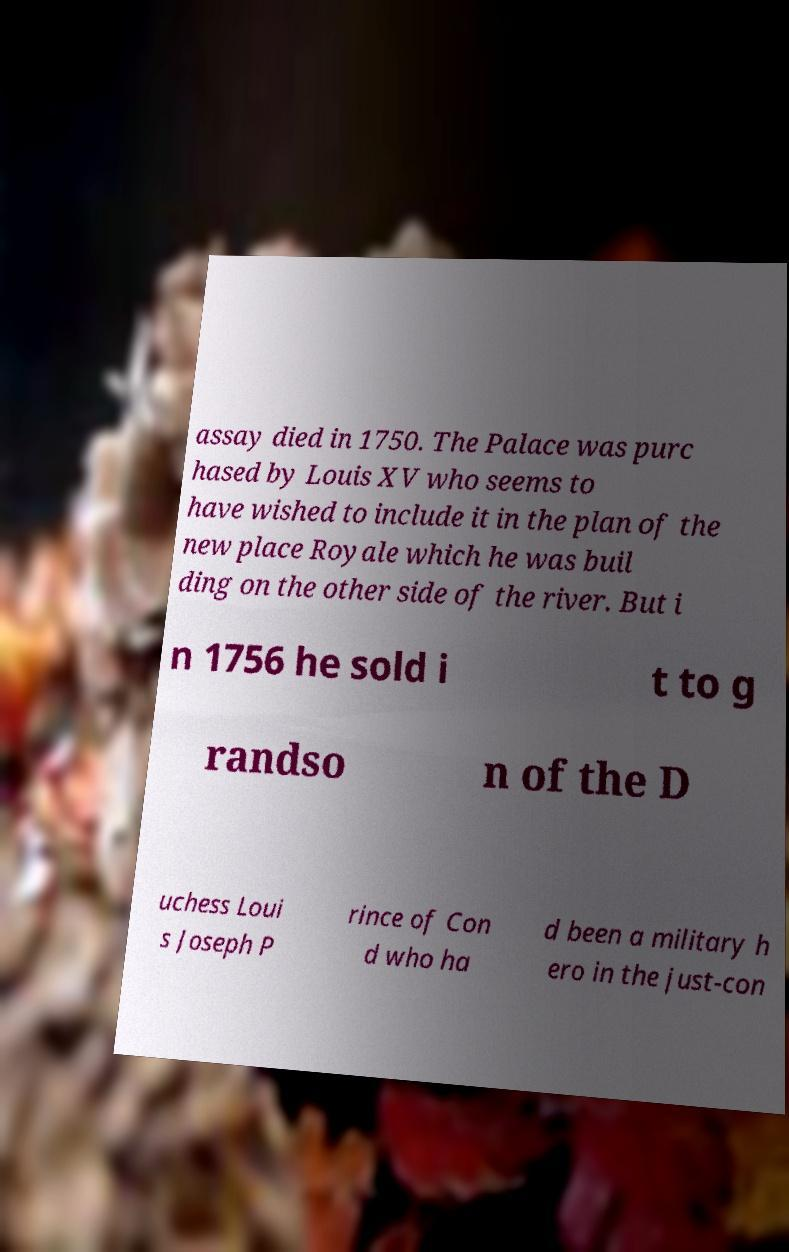There's text embedded in this image that I need extracted. Can you transcribe it verbatim? assay died in 1750. The Palace was purc hased by Louis XV who seems to have wished to include it in the plan of the new place Royale which he was buil ding on the other side of the river. But i n 1756 he sold i t to g randso n of the D uchess Loui s Joseph P rince of Con d who ha d been a military h ero in the just-con 